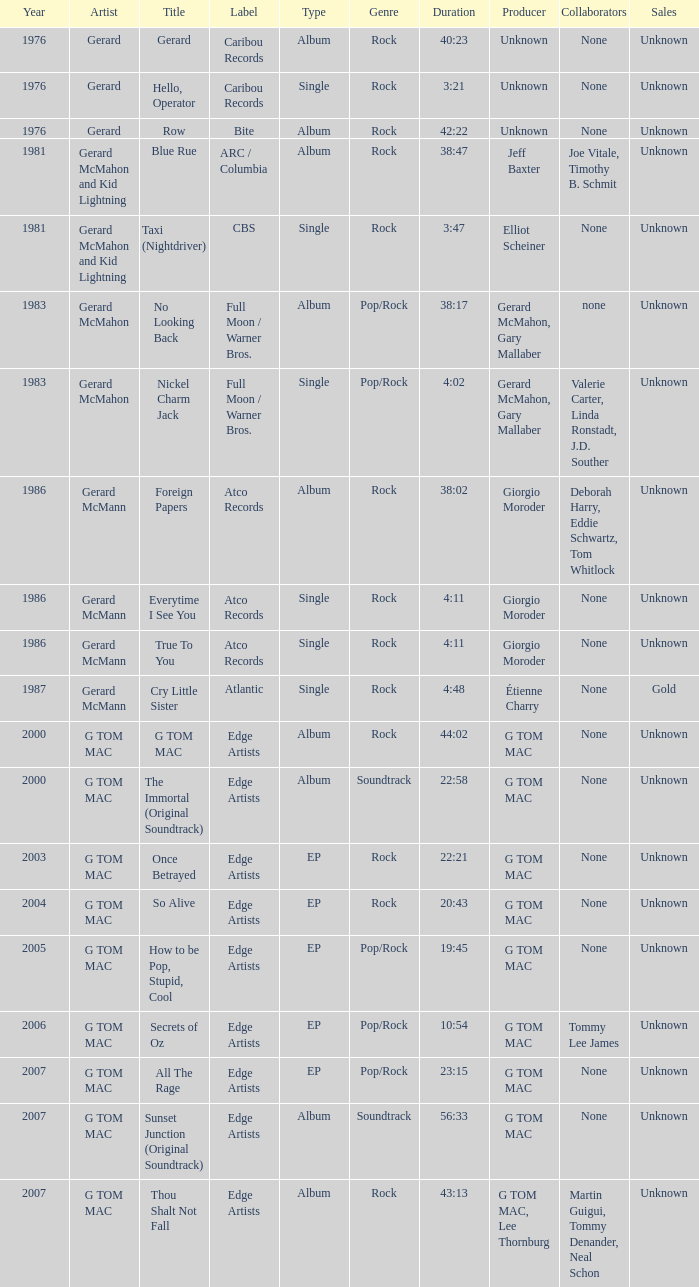Which Title has a Type of album in 1983? No Looking Back. 